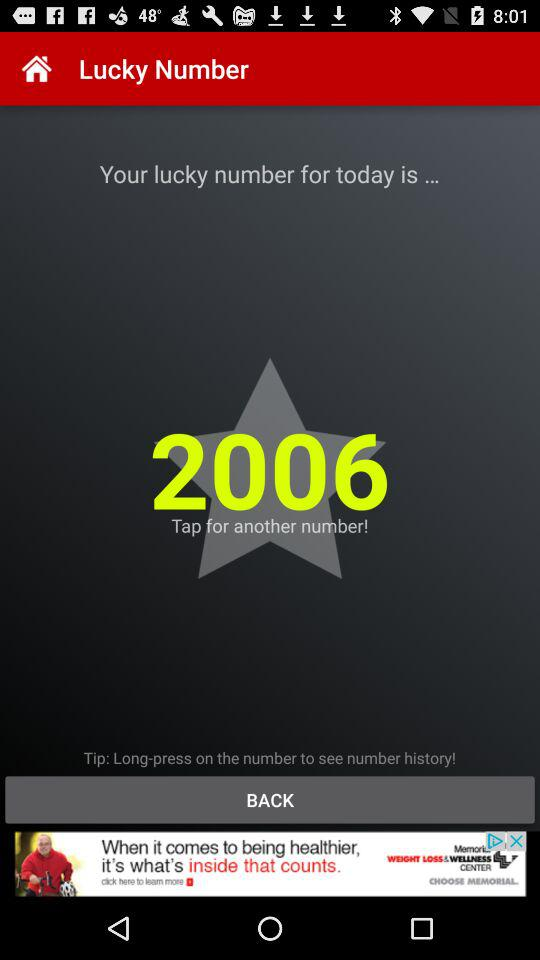What is my lucky number today? Your lucky number for today is 2006. 